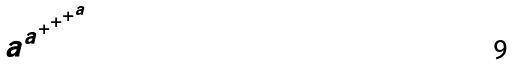<formula> <loc_0><loc_0><loc_500><loc_500>a ^ { a ^ { + ^ { + ^ { + ^ { a } } } } }</formula> 